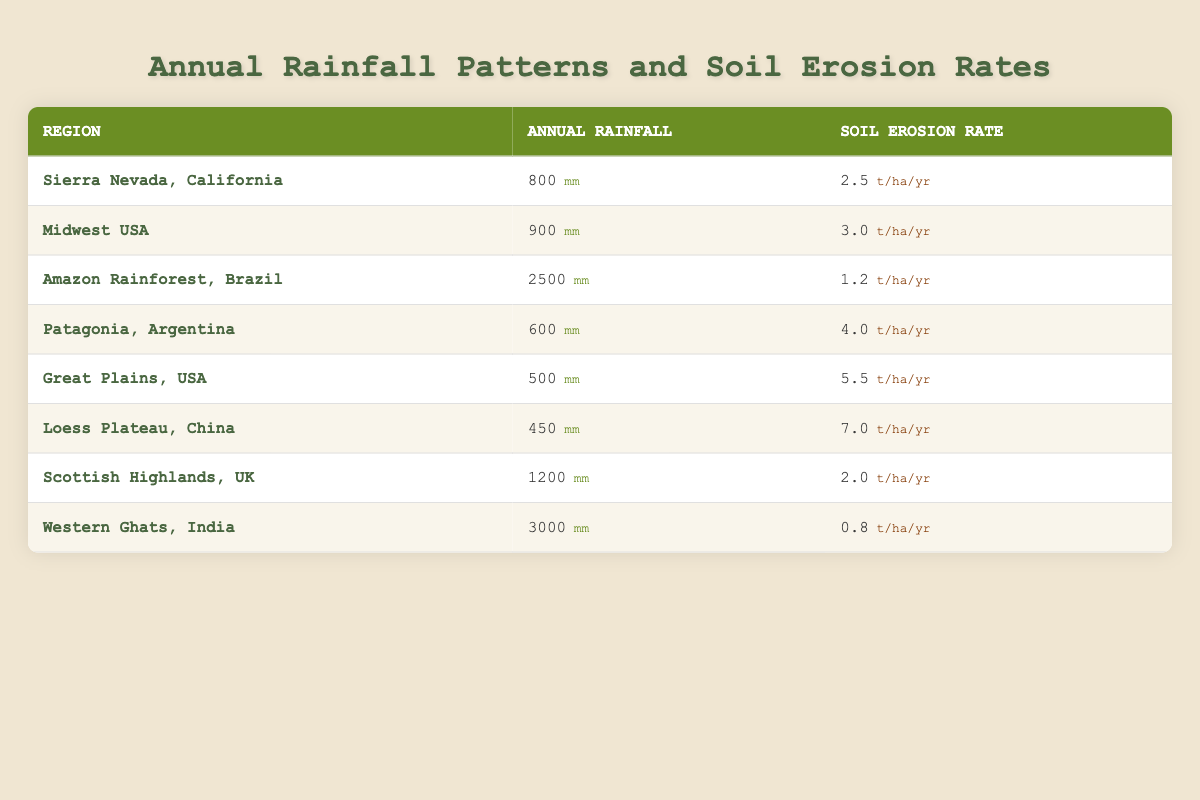What is the soil erosion rate in the Sierra Nevada, California? According to the table, the soil erosion rate for the Sierra Nevada, California is listed directly in the Erosion Rate column as 2.5 tons per hectare per year.
Answer: 2.5 tons per hectare per year Which region has the highest annual rainfall? The region with the highest annual rainfall can be found by scanning the Annual Rainfall column. The Western Ghats, India shows the highest value at 3000 mm.
Answer: 3000 mm What is the soil erosion rate for the region with the lowest annual rainfall? To find the lowest annual rainfall, I scan through the Annual Rainfall column and identify the Great Plains, USA with 500 mm, which corresponds to the Soil Erosion Rate of 5.5 tons per hectare per year.
Answer: 5.5 tons per hectare per year Is the soil erosion rate in the Amazon Rainforest greater than the soil erosion rate in the Scottish Highlands? The erosion rate for the Amazon Rainforest is 1.2, and for the Scottish Highlands, it is 2.0. Comparing these values shows that 1.2 is less than 2.0, indicating that the soil erosion rate in the Amazon Rainforest is not greater.
Answer: No What is the average soil erosion rate for regions with annual rainfall above 1000 mm? The regions above 1000 mm are the Amazon Rainforest (1.2), Scottish Highlands (2.0), and Western Ghats (0.8). First, I sum these rates: 1.2 + 2.0 + 0.8 = 4.0. There are three regions, so the average is 4.0 / 3 = 1.33.
Answer: 1.33 tons per hectare per year How much higher is the soil erosion rate in Loess Plateau, China compared to Patagonia, Argentina? The erosion rate for Loess Plateau is 7.0, and for Patagonia is 4.0. To find the difference, I subtract: 7.0 - 4.0 = 3.0, indicating that the Loess Plateau has a higher rate of 3.0 tons per hectare per year compared to Patagonia.
Answer: 3.0 tons per hectare per year How many regions have a soil erosion rate below 3 tons per hectare per year? Scanning through the Soil Erosion Rate column, the regions with rates below 3 are Amazon Rainforest (1.2), Scottish Highlands (2.0), and Western Ghats (0.8). This gives us a total of 3 regions.
Answer: 3 regions Which region has an annual rainfall closest to 700 mm? Looking at the Annual Rainfall column, I see that Patagonia, Argentina has 600 mm and the Sierra Nevada, California has 800 mm. Since 700 mm is in between 600 mm and 800 mm, I deduce that these two are the closest, but since only Patagonia is below, the answer is that Patagonia is the closest.
Answer: Patagonia, Argentina 